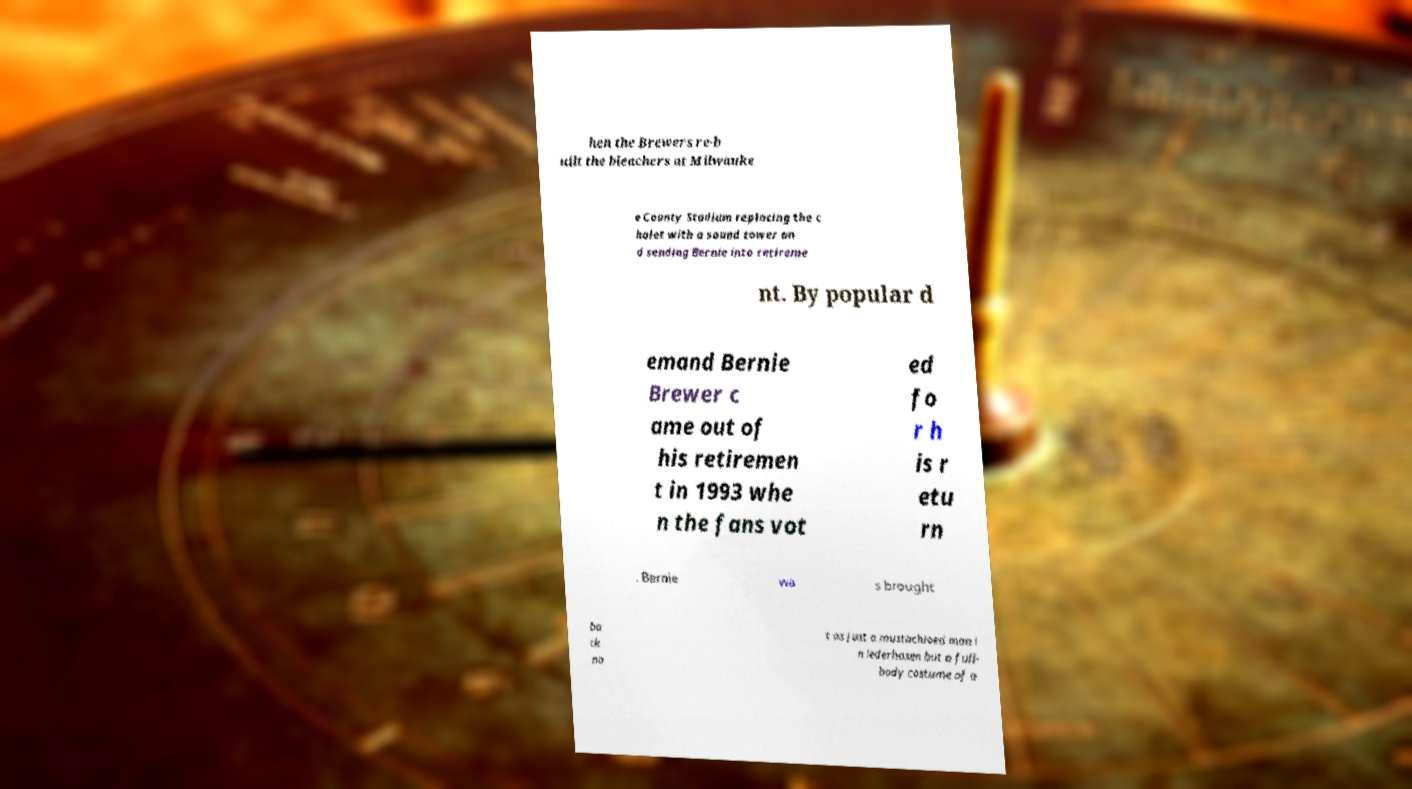Please identify and transcribe the text found in this image. hen the Brewers re-b uilt the bleachers at Milwauke e County Stadium replacing the c halet with a sound tower an d sending Bernie into retireme nt. By popular d emand Bernie Brewer c ame out of his retiremen t in 1993 whe n the fans vot ed fo r h is r etu rn . Bernie wa s brought ba ck no t as just a mustachioed man i n lederhosen but a full- body costume of a 